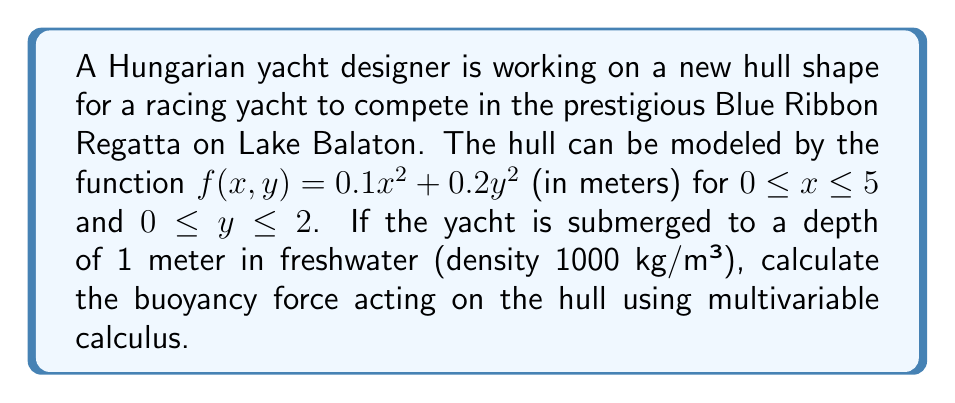Teach me how to tackle this problem. Let's approach this step-by-step:

1) The buoyancy force is equal to the weight of the displaced water. We need to calculate the volume of water displaced and multiply it by the density of water and the acceleration due to gravity.

2) To find the volume, we need to set up a triple integral. The limits for x and y are given, and z will go from 0 to f(x,y) or 1, whichever is smaller.

3) The integral will be:

   $$V = \int_0^5 \int_0^2 \int_0^{\min(f(x,y),1)} dz dy dx$$

4) Substituting f(x,y):

   $$V = \int_0^5 \int_0^2 \int_0^{\min(0.1x^2 + 0.2y^2,1)} dz dy dx$$

5) We can split this into two integrals:

   $$V = \int_0^5 \int_0^2 \int_0^1 dz dy dx - \int_0^5 \int_0^2 \int_{0.1x^2 + 0.2y^2}^1 dz dy dx$$

6) The first integral is simple:

   $$V_1 = \int_0^5 \int_0^2 1 dy dx = 10$$

7) For the second integral:

   $$V_2 = \int_0^5 \int_0^2 (1 - (0.1x^2 + 0.2y^2)) dy dx$$

8) Solving this:

   $$V_2 = \int_0^5 (2 - 0.2x^2 - \frac{4}{3}) dx = 10 - \frac{10}{3} - \frac{100}{3} = \frac{20}{3}$$

9) Therefore, the total volume is:

   $$V = V_1 - V_2 = 10 - \frac{20}{3} = \frac{10}{3}$$

10) The buoyancy force is:

    $$F = \rho g V = 1000 \cdot 9.81 \cdot \frac{10}{3} = 32700 \text{ N}$$
Answer: 32700 N 